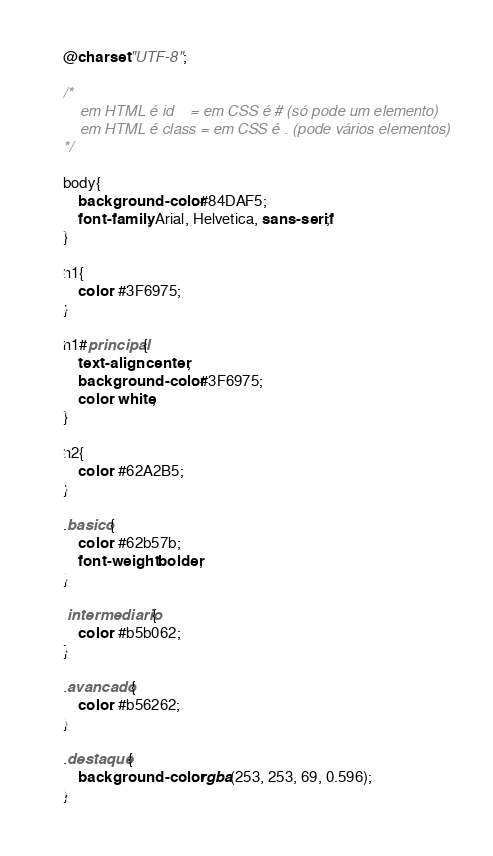<code> <loc_0><loc_0><loc_500><loc_500><_CSS_>@charset "UTF-8";

/*
    em HTML é id    = em CSS é # (só pode um elemento)
    em HTML é class = em CSS é . (pode vários elementos)
*/

body{
    background-color: #84DAF5;
    font-family: Arial, Helvetica, sans-serif;
}

h1{
    color: #3F6975;
}

h1#principal{
    text-align: center;
    background-color: #3F6975;
    color: white;
}

h2{
    color: #62A2B5;
}

.basico{
    color: #62b57b;
    font-weight: bolder;
}

.intermediario{
    color: #b5b062;
}

.avancado{
    color: #b56262;
}

.destaque{
    background-color: rgba(253, 253, 69, 0.596);
}</code> 